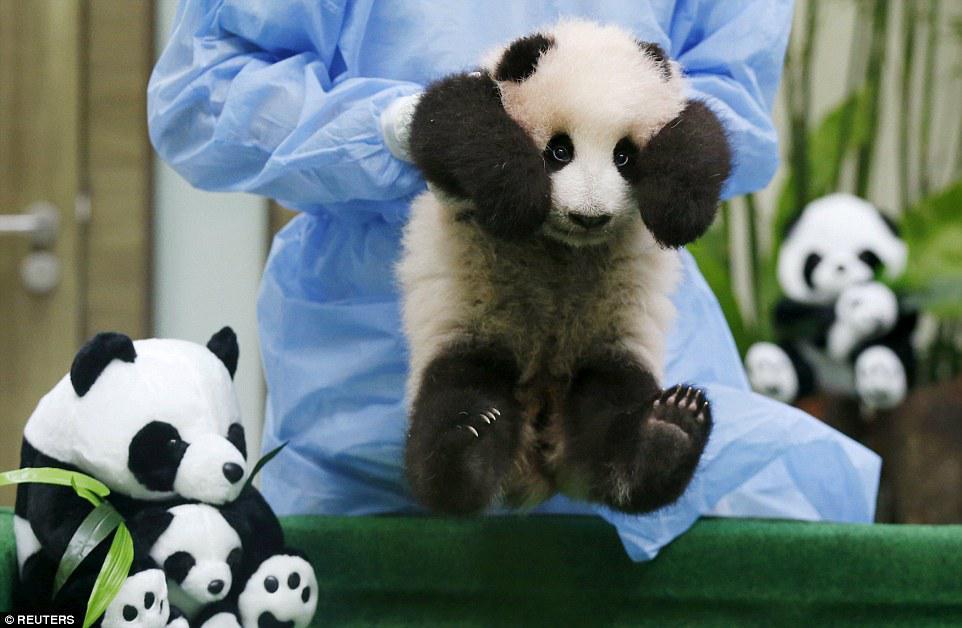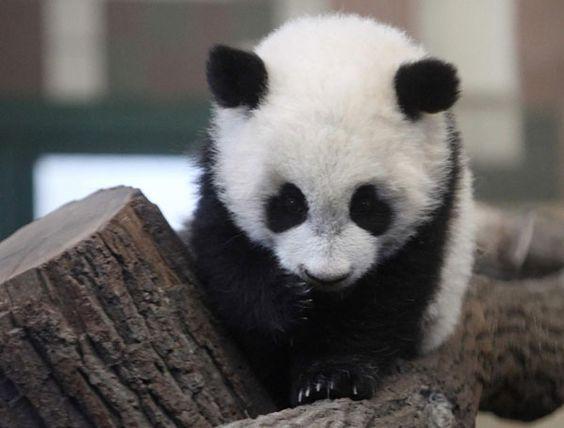The first image is the image on the left, the second image is the image on the right. Given the left and right images, does the statement "In one image, a small panda is being held at an indoor location by a person who is wearing a medical protective item." hold true? Answer yes or no. Yes. The first image is the image on the left, the second image is the image on the right. For the images shown, is this caption "One image contains twice as many pandas as the other image, and one panda has an open mouth and wide-open eyes." true? Answer yes or no. No. 